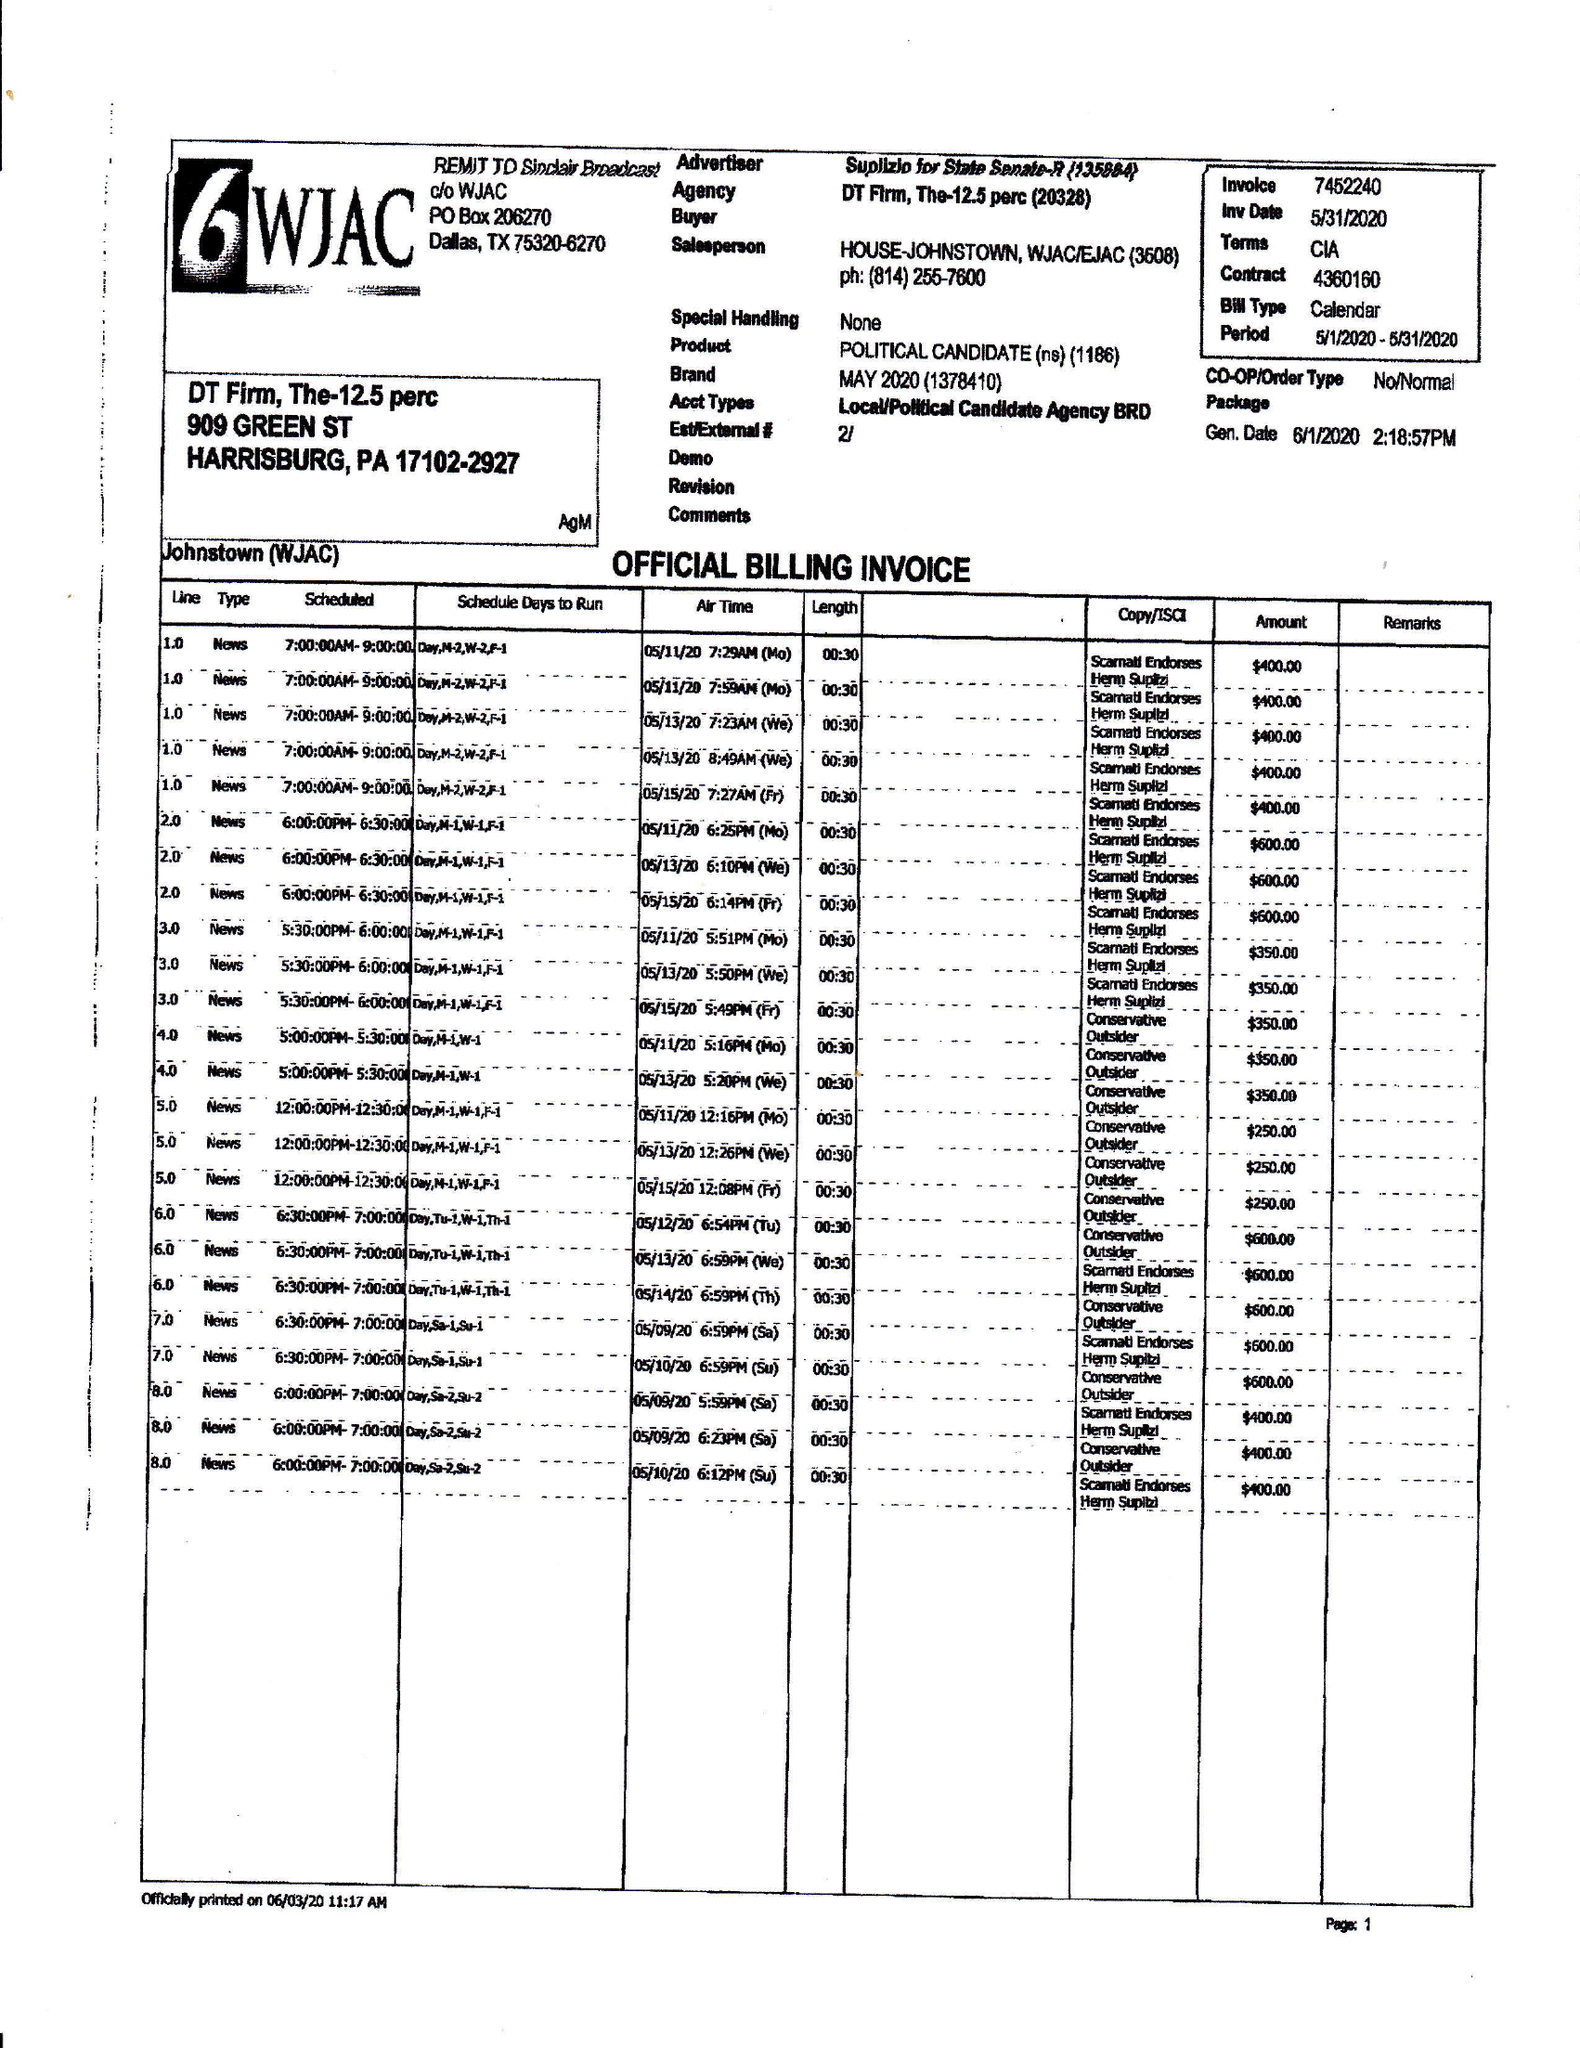What is the value for the advertiser?
Answer the question using a single word or phrase. SUPLIZIO FOR STATE SENATE-R 